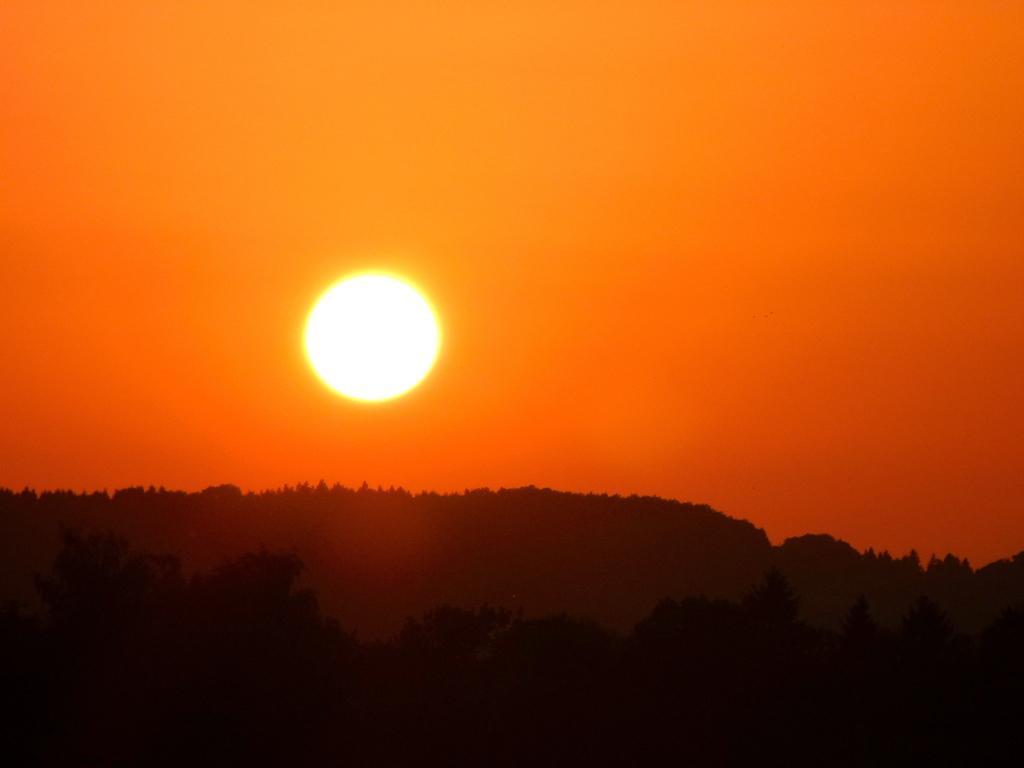Please provide a concise description of this image. In this image we can see sun in the sky and in the background we can see group of trees. 